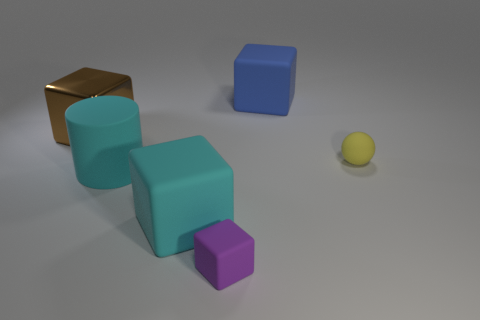There is a cyan matte thing behind the big block that is in front of the big metal cube; what size is it?
Your response must be concise. Large. Is the blue matte object the same size as the brown object?
Provide a succinct answer. Yes. Is the number of tiny rubber objects that are behind the metallic block less than the number of large brown metallic cubes in front of the yellow ball?
Provide a succinct answer. No. What size is the block that is both to the left of the small purple matte object and behind the yellow ball?
Offer a very short reply. Large. There is a ball that is on the right side of the large matte cube that is in front of the yellow matte sphere; are there any big rubber blocks in front of it?
Your answer should be compact. Yes. Are any large blue rubber objects visible?
Provide a succinct answer. Yes. Are there more cyan rubber things that are right of the large cyan block than small things to the right of the tiny yellow matte object?
Your answer should be compact. No. What size is the purple object that is the same material as the tiny ball?
Offer a very short reply. Small. There is a block that is in front of the large rubber block that is on the left side of the big rubber cube to the right of the small purple block; how big is it?
Provide a succinct answer. Small. What is the color of the small matte thing that is behind the small block?
Your response must be concise. Yellow. 